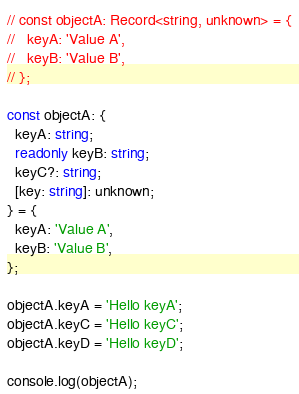Convert code to text. <code><loc_0><loc_0><loc_500><loc_500><_TypeScript_>// const objectA: Record<string, unknown> = {
//   keyA: 'Value A',
//   keyB: 'Value B',
// };

const objectA: {
  keyA: string;
  readonly keyB: string;
  keyC?: string;
  [key: string]: unknown;
} = {
  keyA: 'Value A',
  keyB: 'Value B',
};

objectA.keyA = 'Hello keyA';
objectA.keyC = 'Hello keyC';
objectA.keyD = 'Hello keyD';

console.log(objectA);
</code> 